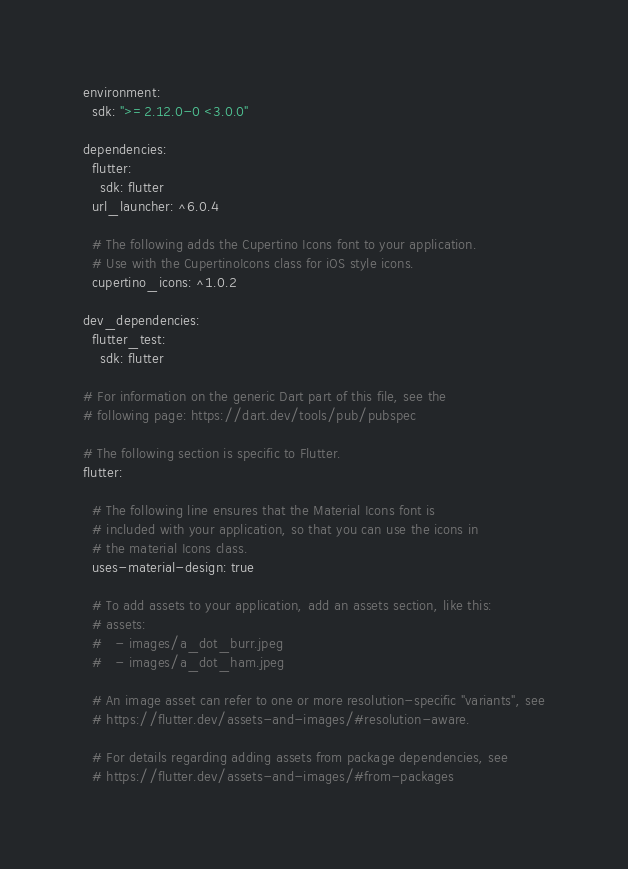<code> <loc_0><loc_0><loc_500><loc_500><_YAML_>environment:
  sdk: ">=2.12.0-0 <3.0.0"

dependencies:
  flutter:
    sdk: flutter
  url_launcher: ^6.0.4

  # The following adds the Cupertino Icons font to your application.
  # Use with the CupertinoIcons class for iOS style icons.
  cupertino_icons: ^1.0.2

dev_dependencies:
  flutter_test:
    sdk: flutter

# For information on the generic Dart part of this file, see the
# following page: https://dart.dev/tools/pub/pubspec

# The following section is specific to Flutter.
flutter:

  # The following line ensures that the Material Icons font is
  # included with your application, so that you can use the icons in
  # the material Icons class.
  uses-material-design: true

  # To add assets to your application, add an assets section, like this:
  # assets:
  #   - images/a_dot_burr.jpeg
  #   - images/a_dot_ham.jpeg

  # An image asset can refer to one or more resolution-specific "variants", see
  # https://flutter.dev/assets-and-images/#resolution-aware.

  # For details regarding adding assets from package dependencies, see
  # https://flutter.dev/assets-and-images/#from-packages
</code> 